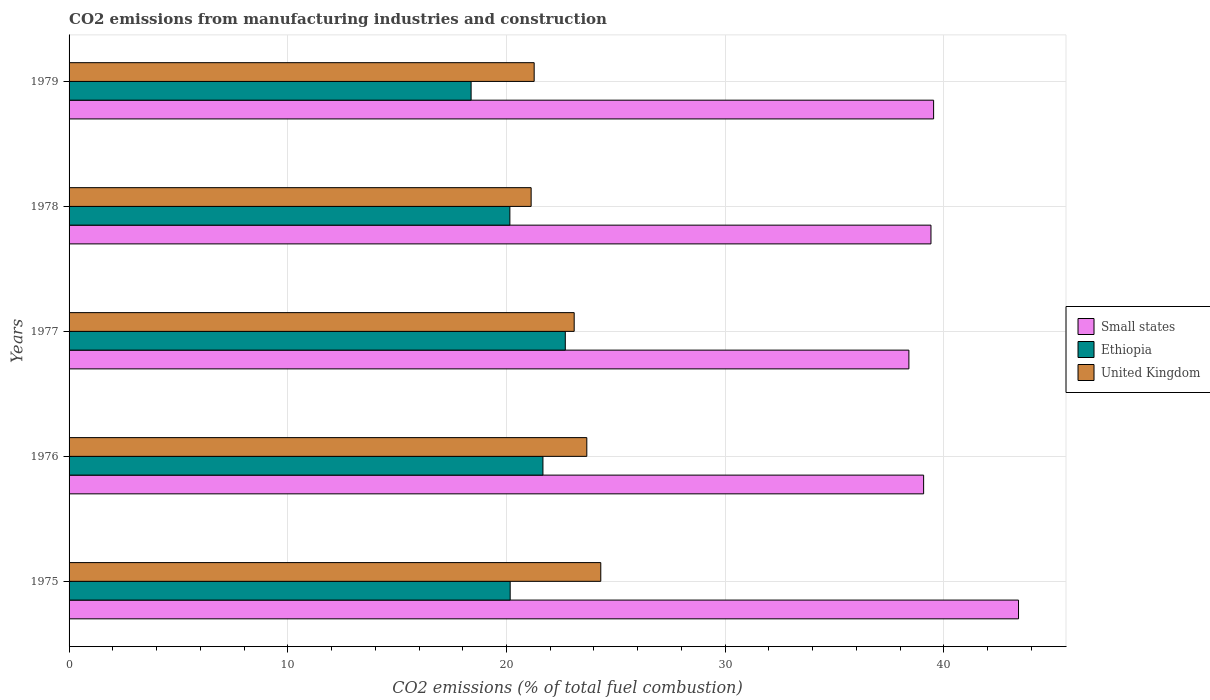How many groups of bars are there?
Give a very brief answer. 5. Are the number of bars per tick equal to the number of legend labels?
Ensure brevity in your answer.  Yes. Are the number of bars on each tick of the Y-axis equal?
Give a very brief answer. Yes. How many bars are there on the 1st tick from the top?
Ensure brevity in your answer.  3. How many bars are there on the 2nd tick from the bottom?
Make the answer very short. 3. What is the label of the 1st group of bars from the top?
Provide a short and direct response. 1979. In how many cases, is the number of bars for a given year not equal to the number of legend labels?
Your response must be concise. 0. What is the amount of CO2 emitted in Small states in 1975?
Offer a terse response. 43.41. Across all years, what is the maximum amount of CO2 emitted in Ethiopia?
Your answer should be very brief. 22.69. Across all years, what is the minimum amount of CO2 emitted in Ethiopia?
Offer a terse response. 18.38. In which year was the amount of CO2 emitted in Ethiopia minimum?
Provide a succinct answer. 1979. What is the total amount of CO2 emitted in United Kingdom in the graph?
Offer a very short reply. 113.47. What is the difference between the amount of CO2 emitted in United Kingdom in 1975 and that in 1978?
Make the answer very short. 3.18. What is the difference between the amount of CO2 emitted in Ethiopia in 1978 and the amount of CO2 emitted in United Kingdom in 1976?
Offer a terse response. -3.52. What is the average amount of CO2 emitted in Small states per year?
Offer a terse response. 39.96. In the year 1977, what is the difference between the amount of CO2 emitted in United Kingdom and amount of CO2 emitted in Small states?
Provide a succinct answer. -15.3. In how many years, is the amount of CO2 emitted in Ethiopia greater than 10 %?
Provide a short and direct response. 5. What is the ratio of the amount of CO2 emitted in Ethiopia in 1977 to that in 1979?
Ensure brevity in your answer.  1.23. Is the amount of CO2 emitted in Small states in 1975 less than that in 1978?
Your answer should be very brief. No. Is the difference between the amount of CO2 emitted in United Kingdom in 1977 and 1978 greater than the difference between the amount of CO2 emitted in Small states in 1977 and 1978?
Offer a very short reply. Yes. What is the difference between the highest and the second highest amount of CO2 emitted in Ethiopia?
Provide a short and direct response. 1.02. What is the difference between the highest and the lowest amount of CO2 emitted in Ethiopia?
Your answer should be very brief. 4.31. In how many years, is the amount of CO2 emitted in United Kingdom greater than the average amount of CO2 emitted in United Kingdom taken over all years?
Provide a short and direct response. 3. What does the 3rd bar from the top in 1976 represents?
Offer a terse response. Small states. What does the 3rd bar from the bottom in 1975 represents?
Offer a terse response. United Kingdom. How many bars are there?
Offer a very short reply. 15. What is the difference between two consecutive major ticks on the X-axis?
Offer a very short reply. 10. Are the values on the major ticks of X-axis written in scientific E-notation?
Give a very brief answer. No. Does the graph contain any zero values?
Provide a succinct answer. No. Does the graph contain grids?
Provide a succinct answer. Yes. Where does the legend appear in the graph?
Offer a terse response. Center right. What is the title of the graph?
Ensure brevity in your answer.  CO2 emissions from manufacturing industries and construction. Does "South Africa" appear as one of the legend labels in the graph?
Ensure brevity in your answer.  No. What is the label or title of the X-axis?
Make the answer very short. CO2 emissions (% of total fuel combustion). What is the label or title of the Y-axis?
Your answer should be compact. Years. What is the CO2 emissions (% of total fuel combustion) of Small states in 1975?
Your response must be concise. 43.41. What is the CO2 emissions (% of total fuel combustion) in Ethiopia in 1975?
Offer a terse response. 20.17. What is the CO2 emissions (% of total fuel combustion) in United Kingdom in 1975?
Your response must be concise. 24.31. What is the CO2 emissions (% of total fuel combustion) in Small states in 1976?
Your response must be concise. 39.07. What is the CO2 emissions (% of total fuel combustion) in Ethiopia in 1976?
Offer a very short reply. 21.67. What is the CO2 emissions (% of total fuel combustion) in United Kingdom in 1976?
Your response must be concise. 23.67. What is the CO2 emissions (% of total fuel combustion) in Small states in 1977?
Your answer should be compact. 38.4. What is the CO2 emissions (% of total fuel combustion) in Ethiopia in 1977?
Ensure brevity in your answer.  22.69. What is the CO2 emissions (% of total fuel combustion) of United Kingdom in 1977?
Provide a short and direct response. 23.1. What is the CO2 emissions (% of total fuel combustion) in Small states in 1978?
Keep it short and to the point. 39.41. What is the CO2 emissions (% of total fuel combustion) of Ethiopia in 1978?
Keep it short and to the point. 20.16. What is the CO2 emissions (% of total fuel combustion) of United Kingdom in 1978?
Provide a short and direct response. 21.13. What is the CO2 emissions (% of total fuel combustion) in Small states in 1979?
Make the answer very short. 39.53. What is the CO2 emissions (% of total fuel combustion) of Ethiopia in 1979?
Keep it short and to the point. 18.38. What is the CO2 emissions (% of total fuel combustion) of United Kingdom in 1979?
Your answer should be compact. 21.27. Across all years, what is the maximum CO2 emissions (% of total fuel combustion) in Small states?
Provide a succinct answer. 43.41. Across all years, what is the maximum CO2 emissions (% of total fuel combustion) in Ethiopia?
Keep it short and to the point. 22.69. Across all years, what is the maximum CO2 emissions (% of total fuel combustion) in United Kingdom?
Keep it short and to the point. 24.31. Across all years, what is the minimum CO2 emissions (% of total fuel combustion) in Small states?
Offer a terse response. 38.4. Across all years, what is the minimum CO2 emissions (% of total fuel combustion) of Ethiopia?
Offer a terse response. 18.38. Across all years, what is the minimum CO2 emissions (% of total fuel combustion) of United Kingdom?
Provide a short and direct response. 21.13. What is the total CO2 emissions (% of total fuel combustion) in Small states in the graph?
Offer a terse response. 199.82. What is the total CO2 emissions (% of total fuel combustion) in Ethiopia in the graph?
Keep it short and to the point. 103.06. What is the total CO2 emissions (% of total fuel combustion) of United Kingdom in the graph?
Your response must be concise. 113.47. What is the difference between the CO2 emissions (% of total fuel combustion) of Small states in 1975 and that in 1976?
Your response must be concise. 4.34. What is the difference between the CO2 emissions (% of total fuel combustion) in Ethiopia in 1975 and that in 1976?
Your answer should be compact. -1.5. What is the difference between the CO2 emissions (% of total fuel combustion) in United Kingdom in 1975 and that in 1976?
Offer a terse response. 0.64. What is the difference between the CO2 emissions (% of total fuel combustion) in Small states in 1975 and that in 1977?
Your answer should be very brief. 5.01. What is the difference between the CO2 emissions (% of total fuel combustion) of Ethiopia in 1975 and that in 1977?
Ensure brevity in your answer.  -2.52. What is the difference between the CO2 emissions (% of total fuel combustion) of United Kingdom in 1975 and that in 1977?
Provide a short and direct response. 1.22. What is the difference between the CO2 emissions (% of total fuel combustion) of Small states in 1975 and that in 1978?
Keep it short and to the point. 4. What is the difference between the CO2 emissions (% of total fuel combustion) of Ethiopia in 1975 and that in 1978?
Your answer should be very brief. 0.01. What is the difference between the CO2 emissions (% of total fuel combustion) in United Kingdom in 1975 and that in 1978?
Your answer should be compact. 3.18. What is the difference between the CO2 emissions (% of total fuel combustion) in Small states in 1975 and that in 1979?
Your answer should be compact. 3.88. What is the difference between the CO2 emissions (% of total fuel combustion) of Ethiopia in 1975 and that in 1979?
Your answer should be very brief. 1.79. What is the difference between the CO2 emissions (% of total fuel combustion) in United Kingdom in 1975 and that in 1979?
Your response must be concise. 3.05. What is the difference between the CO2 emissions (% of total fuel combustion) of Small states in 1976 and that in 1977?
Ensure brevity in your answer.  0.67. What is the difference between the CO2 emissions (% of total fuel combustion) in Ethiopia in 1976 and that in 1977?
Give a very brief answer. -1.02. What is the difference between the CO2 emissions (% of total fuel combustion) of United Kingdom in 1976 and that in 1977?
Make the answer very short. 0.58. What is the difference between the CO2 emissions (% of total fuel combustion) of Small states in 1976 and that in 1978?
Offer a very short reply. -0.34. What is the difference between the CO2 emissions (% of total fuel combustion) of Ethiopia in 1976 and that in 1978?
Give a very brief answer. 1.51. What is the difference between the CO2 emissions (% of total fuel combustion) of United Kingdom in 1976 and that in 1978?
Your answer should be very brief. 2.55. What is the difference between the CO2 emissions (% of total fuel combustion) in Small states in 1976 and that in 1979?
Provide a short and direct response. -0.46. What is the difference between the CO2 emissions (% of total fuel combustion) in Ethiopia in 1976 and that in 1979?
Give a very brief answer. 3.28. What is the difference between the CO2 emissions (% of total fuel combustion) in United Kingdom in 1976 and that in 1979?
Your response must be concise. 2.41. What is the difference between the CO2 emissions (% of total fuel combustion) in Small states in 1977 and that in 1978?
Offer a terse response. -1.01. What is the difference between the CO2 emissions (% of total fuel combustion) of Ethiopia in 1977 and that in 1978?
Your answer should be very brief. 2.53. What is the difference between the CO2 emissions (% of total fuel combustion) of United Kingdom in 1977 and that in 1978?
Offer a very short reply. 1.97. What is the difference between the CO2 emissions (% of total fuel combustion) of Small states in 1977 and that in 1979?
Your answer should be very brief. -1.13. What is the difference between the CO2 emissions (% of total fuel combustion) of Ethiopia in 1977 and that in 1979?
Your answer should be very brief. 4.31. What is the difference between the CO2 emissions (% of total fuel combustion) in United Kingdom in 1977 and that in 1979?
Offer a very short reply. 1.83. What is the difference between the CO2 emissions (% of total fuel combustion) of Small states in 1978 and that in 1979?
Your response must be concise. -0.12. What is the difference between the CO2 emissions (% of total fuel combustion) in Ethiopia in 1978 and that in 1979?
Your answer should be compact. 1.77. What is the difference between the CO2 emissions (% of total fuel combustion) of United Kingdom in 1978 and that in 1979?
Offer a terse response. -0.14. What is the difference between the CO2 emissions (% of total fuel combustion) in Small states in 1975 and the CO2 emissions (% of total fuel combustion) in Ethiopia in 1976?
Provide a short and direct response. 21.75. What is the difference between the CO2 emissions (% of total fuel combustion) in Small states in 1975 and the CO2 emissions (% of total fuel combustion) in United Kingdom in 1976?
Make the answer very short. 19.74. What is the difference between the CO2 emissions (% of total fuel combustion) in Ethiopia in 1975 and the CO2 emissions (% of total fuel combustion) in United Kingdom in 1976?
Make the answer very short. -3.5. What is the difference between the CO2 emissions (% of total fuel combustion) of Small states in 1975 and the CO2 emissions (% of total fuel combustion) of Ethiopia in 1977?
Your answer should be compact. 20.72. What is the difference between the CO2 emissions (% of total fuel combustion) in Small states in 1975 and the CO2 emissions (% of total fuel combustion) in United Kingdom in 1977?
Provide a short and direct response. 20.32. What is the difference between the CO2 emissions (% of total fuel combustion) in Ethiopia in 1975 and the CO2 emissions (% of total fuel combustion) in United Kingdom in 1977?
Make the answer very short. -2.93. What is the difference between the CO2 emissions (% of total fuel combustion) of Small states in 1975 and the CO2 emissions (% of total fuel combustion) of Ethiopia in 1978?
Provide a succinct answer. 23.26. What is the difference between the CO2 emissions (% of total fuel combustion) in Small states in 1975 and the CO2 emissions (% of total fuel combustion) in United Kingdom in 1978?
Give a very brief answer. 22.29. What is the difference between the CO2 emissions (% of total fuel combustion) of Ethiopia in 1975 and the CO2 emissions (% of total fuel combustion) of United Kingdom in 1978?
Keep it short and to the point. -0.96. What is the difference between the CO2 emissions (% of total fuel combustion) of Small states in 1975 and the CO2 emissions (% of total fuel combustion) of Ethiopia in 1979?
Offer a very short reply. 25.03. What is the difference between the CO2 emissions (% of total fuel combustion) of Small states in 1975 and the CO2 emissions (% of total fuel combustion) of United Kingdom in 1979?
Provide a short and direct response. 22.15. What is the difference between the CO2 emissions (% of total fuel combustion) of Ethiopia in 1975 and the CO2 emissions (% of total fuel combustion) of United Kingdom in 1979?
Provide a short and direct response. -1.1. What is the difference between the CO2 emissions (% of total fuel combustion) in Small states in 1976 and the CO2 emissions (% of total fuel combustion) in Ethiopia in 1977?
Offer a very short reply. 16.38. What is the difference between the CO2 emissions (% of total fuel combustion) of Small states in 1976 and the CO2 emissions (% of total fuel combustion) of United Kingdom in 1977?
Keep it short and to the point. 15.98. What is the difference between the CO2 emissions (% of total fuel combustion) of Ethiopia in 1976 and the CO2 emissions (% of total fuel combustion) of United Kingdom in 1977?
Your answer should be very brief. -1.43. What is the difference between the CO2 emissions (% of total fuel combustion) in Small states in 1976 and the CO2 emissions (% of total fuel combustion) in Ethiopia in 1978?
Ensure brevity in your answer.  18.92. What is the difference between the CO2 emissions (% of total fuel combustion) of Small states in 1976 and the CO2 emissions (% of total fuel combustion) of United Kingdom in 1978?
Ensure brevity in your answer.  17.95. What is the difference between the CO2 emissions (% of total fuel combustion) in Ethiopia in 1976 and the CO2 emissions (% of total fuel combustion) in United Kingdom in 1978?
Your answer should be compact. 0.54. What is the difference between the CO2 emissions (% of total fuel combustion) of Small states in 1976 and the CO2 emissions (% of total fuel combustion) of Ethiopia in 1979?
Ensure brevity in your answer.  20.69. What is the difference between the CO2 emissions (% of total fuel combustion) in Small states in 1976 and the CO2 emissions (% of total fuel combustion) in United Kingdom in 1979?
Provide a succinct answer. 17.81. What is the difference between the CO2 emissions (% of total fuel combustion) of Ethiopia in 1976 and the CO2 emissions (% of total fuel combustion) of United Kingdom in 1979?
Make the answer very short. 0.4. What is the difference between the CO2 emissions (% of total fuel combustion) in Small states in 1977 and the CO2 emissions (% of total fuel combustion) in Ethiopia in 1978?
Provide a short and direct response. 18.24. What is the difference between the CO2 emissions (% of total fuel combustion) of Small states in 1977 and the CO2 emissions (% of total fuel combustion) of United Kingdom in 1978?
Offer a very short reply. 17.27. What is the difference between the CO2 emissions (% of total fuel combustion) of Ethiopia in 1977 and the CO2 emissions (% of total fuel combustion) of United Kingdom in 1978?
Provide a succinct answer. 1.56. What is the difference between the CO2 emissions (% of total fuel combustion) of Small states in 1977 and the CO2 emissions (% of total fuel combustion) of Ethiopia in 1979?
Offer a very short reply. 20.02. What is the difference between the CO2 emissions (% of total fuel combustion) of Small states in 1977 and the CO2 emissions (% of total fuel combustion) of United Kingdom in 1979?
Your answer should be very brief. 17.13. What is the difference between the CO2 emissions (% of total fuel combustion) in Ethiopia in 1977 and the CO2 emissions (% of total fuel combustion) in United Kingdom in 1979?
Ensure brevity in your answer.  1.42. What is the difference between the CO2 emissions (% of total fuel combustion) of Small states in 1978 and the CO2 emissions (% of total fuel combustion) of Ethiopia in 1979?
Make the answer very short. 21.03. What is the difference between the CO2 emissions (% of total fuel combustion) of Small states in 1978 and the CO2 emissions (% of total fuel combustion) of United Kingdom in 1979?
Make the answer very short. 18.14. What is the difference between the CO2 emissions (% of total fuel combustion) of Ethiopia in 1978 and the CO2 emissions (% of total fuel combustion) of United Kingdom in 1979?
Offer a terse response. -1.11. What is the average CO2 emissions (% of total fuel combustion) of Small states per year?
Offer a terse response. 39.96. What is the average CO2 emissions (% of total fuel combustion) in Ethiopia per year?
Your answer should be very brief. 20.61. What is the average CO2 emissions (% of total fuel combustion) in United Kingdom per year?
Your response must be concise. 22.69. In the year 1975, what is the difference between the CO2 emissions (% of total fuel combustion) of Small states and CO2 emissions (% of total fuel combustion) of Ethiopia?
Offer a terse response. 23.24. In the year 1975, what is the difference between the CO2 emissions (% of total fuel combustion) of Small states and CO2 emissions (% of total fuel combustion) of United Kingdom?
Provide a short and direct response. 19.1. In the year 1975, what is the difference between the CO2 emissions (% of total fuel combustion) of Ethiopia and CO2 emissions (% of total fuel combustion) of United Kingdom?
Keep it short and to the point. -4.14. In the year 1976, what is the difference between the CO2 emissions (% of total fuel combustion) of Small states and CO2 emissions (% of total fuel combustion) of Ethiopia?
Your answer should be very brief. 17.41. In the year 1976, what is the difference between the CO2 emissions (% of total fuel combustion) of Small states and CO2 emissions (% of total fuel combustion) of United Kingdom?
Offer a very short reply. 15.4. In the year 1976, what is the difference between the CO2 emissions (% of total fuel combustion) in Ethiopia and CO2 emissions (% of total fuel combustion) in United Kingdom?
Ensure brevity in your answer.  -2.01. In the year 1977, what is the difference between the CO2 emissions (% of total fuel combustion) in Small states and CO2 emissions (% of total fuel combustion) in Ethiopia?
Your response must be concise. 15.71. In the year 1977, what is the difference between the CO2 emissions (% of total fuel combustion) of Small states and CO2 emissions (% of total fuel combustion) of United Kingdom?
Provide a succinct answer. 15.3. In the year 1977, what is the difference between the CO2 emissions (% of total fuel combustion) in Ethiopia and CO2 emissions (% of total fuel combustion) in United Kingdom?
Provide a short and direct response. -0.41. In the year 1978, what is the difference between the CO2 emissions (% of total fuel combustion) in Small states and CO2 emissions (% of total fuel combustion) in Ethiopia?
Your answer should be compact. 19.25. In the year 1978, what is the difference between the CO2 emissions (% of total fuel combustion) in Small states and CO2 emissions (% of total fuel combustion) in United Kingdom?
Offer a terse response. 18.28. In the year 1978, what is the difference between the CO2 emissions (% of total fuel combustion) of Ethiopia and CO2 emissions (% of total fuel combustion) of United Kingdom?
Your response must be concise. -0.97. In the year 1979, what is the difference between the CO2 emissions (% of total fuel combustion) in Small states and CO2 emissions (% of total fuel combustion) in Ethiopia?
Give a very brief answer. 21.15. In the year 1979, what is the difference between the CO2 emissions (% of total fuel combustion) of Small states and CO2 emissions (% of total fuel combustion) of United Kingdom?
Make the answer very short. 18.26. In the year 1979, what is the difference between the CO2 emissions (% of total fuel combustion) in Ethiopia and CO2 emissions (% of total fuel combustion) in United Kingdom?
Provide a succinct answer. -2.88. What is the ratio of the CO2 emissions (% of total fuel combustion) of Small states in 1975 to that in 1976?
Offer a very short reply. 1.11. What is the ratio of the CO2 emissions (% of total fuel combustion) of Ethiopia in 1975 to that in 1976?
Provide a short and direct response. 0.93. What is the ratio of the CO2 emissions (% of total fuel combustion) in Small states in 1975 to that in 1977?
Provide a short and direct response. 1.13. What is the ratio of the CO2 emissions (% of total fuel combustion) in United Kingdom in 1975 to that in 1977?
Your answer should be very brief. 1.05. What is the ratio of the CO2 emissions (% of total fuel combustion) of Small states in 1975 to that in 1978?
Provide a succinct answer. 1.1. What is the ratio of the CO2 emissions (% of total fuel combustion) of Ethiopia in 1975 to that in 1978?
Make the answer very short. 1. What is the ratio of the CO2 emissions (% of total fuel combustion) in United Kingdom in 1975 to that in 1978?
Provide a succinct answer. 1.15. What is the ratio of the CO2 emissions (% of total fuel combustion) of Small states in 1975 to that in 1979?
Ensure brevity in your answer.  1.1. What is the ratio of the CO2 emissions (% of total fuel combustion) in Ethiopia in 1975 to that in 1979?
Make the answer very short. 1.1. What is the ratio of the CO2 emissions (% of total fuel combustion) in United Kingdom in 1975 to that in 1979?
Offer a very short reply. 1.14. What is the ratio of the CO2 emissions (% of total fuel combustion) in Small states in 1976 to that in 1977?
Ensure brevity in your answer.  1.02. What is the ratio of the CO2 emissions (% of total fuel combustion) in Ethiopia in 1976 to that in 1977?
Your response must be concise. 0.95. What is the ratio of the CO2 emissions (% of total fuel combustion) of Small states in 1976 to that in 1978?
Keep it short and to the point. 0.99. What is the ratio of the CO2 emissions (% of total fuel combustion) of Ethiopia in 1976 to that in 1978?
Ensure brevity in your answer.  1.07. What is the ratio of the CO2 emissions (% of total fuel combustion) in United Kingdom in 1976 to that in 1978?
Your response must be concise. 1.12. What is the ratio of the CO2 emissions (% of total fuel combustion) in Small states in 1976 to that in 1979?
Your answer should be compact. 0.99. What is the ratio of the CO2 emissions (% of total fuel combustion) in Ethiopia in 1976 to that in 1979?
Offer a terse response. 1.18. What is the ratio of the CO2 emissions (% of total fuel combustion) of United Kingdom in 1976 to that in 1979?
Your answer should be very brief. 1.11. What is the ratio of the CO2 emissions (% of total fuel combustion) of Small states in 1977 to that in 1978?
Your response must be concise. 0.97. What is the ratio of the CO2 emissions (% of total fuel combustion) of Ethiopia in 1977 to that in 1978?
Your response must be concise. 1.13. What is the ratio of the CO2 emissions (% of total fuel combustion) of United Kingdom in 1977 to that in 1978?
Make the answer very short. 1.09. What is the ratio of the CO2 emissions (% of total fuel combustion) in Small states in 1977 to that in 1979?
Your response must be concise. 0.97. What is the ratio of the CO2 emissions (% of total fuel combustion) of Ethiopia in 1977 to that in 1979?
Provide a short and direct response. 1.23. What is the ratio of the CO2 emissions (% of total fuel combustion) in United Kingdom in 1977 to that in 1979?
Make the answer very short. 1.09. What is the ratio of the CO2 emissions (% of total fuel combustion) of Small states in 1978 to that in 1979?
Keep it short and to the point. 1. What is the ratio of the CO2 emissions (% of total fuel combustion) of Ethiopia in 1978 to that in 1979?
Offer a terse response. 1.1. What is the ratio of the CO2 emissions (% of total fuel combustion) of United Kingdom in 1978 to that in 1979?
Your answer should be very brief. 0.99. What is the difference between the highest and the second highest CO2 emissions (% of total fuel combustion) in Small states?
Provide a succinct answer. 3.88. What is the difference between the highest and the second highest CO2 emissions (% of total fuel combustion) of Ethiopia?
Keep it short and to the point. 1.02. What is the difference between the highest and the second highest CO2 emissions (% of total fuel combustion) of United Kingdom?
Give a very brief answer. 0.64. What is the difference between the highest and the lowest CO2 emissions (% of total fuel combustion) of Small states?
Give a very brief answer. 5.01. What is the difference between the highest and the lowest CO2 emissions (% of total fuel combustion) of Ethiopia?
Provide a succinct answer. 4.31. What is the difference between the highest and the lowest CO2 emissions (% of total fuel combustion) in United Kingdom?
Provide a short and direct response. 3.18. 